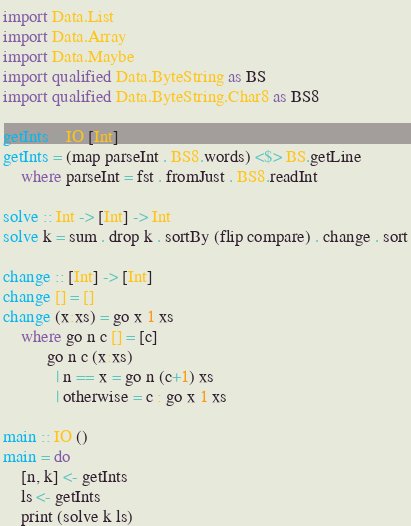Convert code to text. <code><loc_0><loc_0><loc_500><loc_500><_Haskell_>import Data.List
import Data.Array
import Data.Maybe
import qualified Data.ByteString as BS
import qualified Data.ByteString.Char8 as BS8
 
getInts :: IO [Int]
getInts = (map parseInt . BS8.words) <$> BS.getLine 
    where parseInt = fst . fromJust . BS8.readInt
 
solve :: Int -> [Int] -> Int
solve k = sum . drop k . sortBy (flip compare) . change . sort
 
change :: [Int] -> [Int]
change [] = []
change (x:xs) = go x 1 xs
    where go n c [] = [c]
          go n c (x:xs)
            | n == x = go n (c+1) xs
            | otherwise = c : go x 1 xs 
 
main :: IO ()
main = do
    [n, k] <- getInts
    ls <- getInts
    print (solve k ls)</code> 